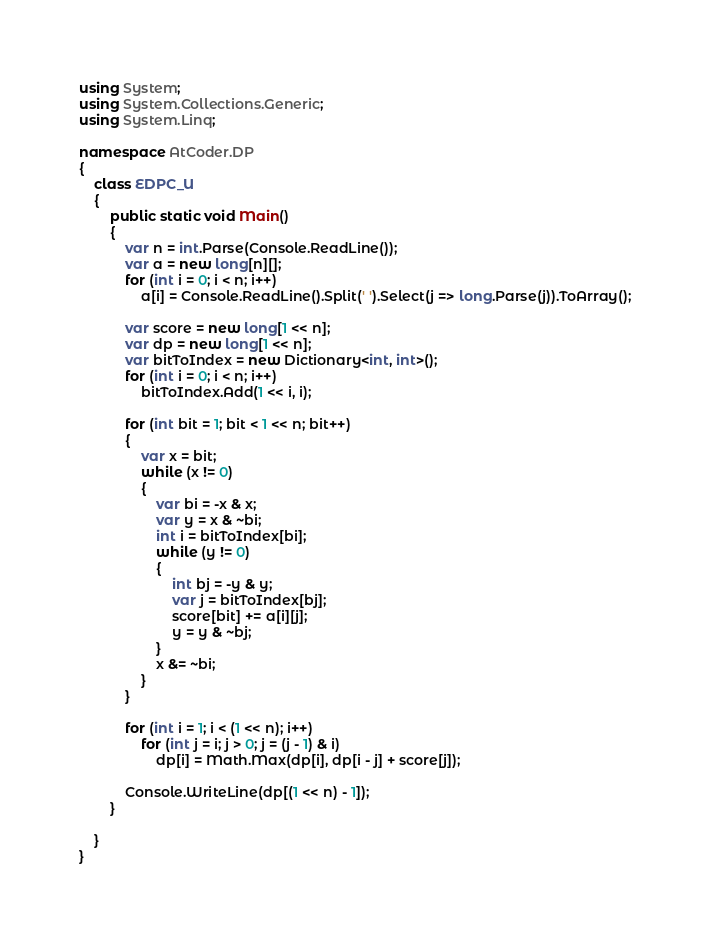Convert code to text. <code><loc_0><loc_0><loc_500><loc_500><_C#_>using System;
using System.Collections.Generic;
using System.Linq;

namespace AtCoder.DP
{
    class EDPC_U
    {
        public static void Main()
        {
            var n = int.Parse(Console.ReadLine());
            var a = new long[n][];
            for (int i = 0; i < n; i++)
                a[i] = Console.ReadLine().Split(' ').Select(j => long.Parse(j)).ToArray();

            var score = new long[1 << n];
            var dp = new long[1 << n];
            var bitToIndex = new Dictionary<int, int>();
            for (int i = 0; i < n; i++)
                bitToIndex.Add(1 << i, i);

            for (int bit = 1; bit < 1 << n; bit++)
            {
                var x = bit;
                while (x != 0)
                {
                    var bi = -x & x;
                    var y = x & ~bi;
                    int i = bitToIndex[bi];
                    while (y != 0)
                    {
                        int bj = -y & y;
                        var j = bitToIndex[bj];
                        score[bit] += a[i][j];
                        y = y & ~bj;
                    }
                    x &= ~bi;
                }
            }

            for (int i = 1; i < (1 << n); i++)
                for (int j = i; j > 0; j = (j - 1) & i)
                    dp[i] = Math.Max(dp[i], dp[i - j] + score[j]);

            Console.WriteLine(dp[(1 << n) - 1]);
        }

    }
}
</code> 